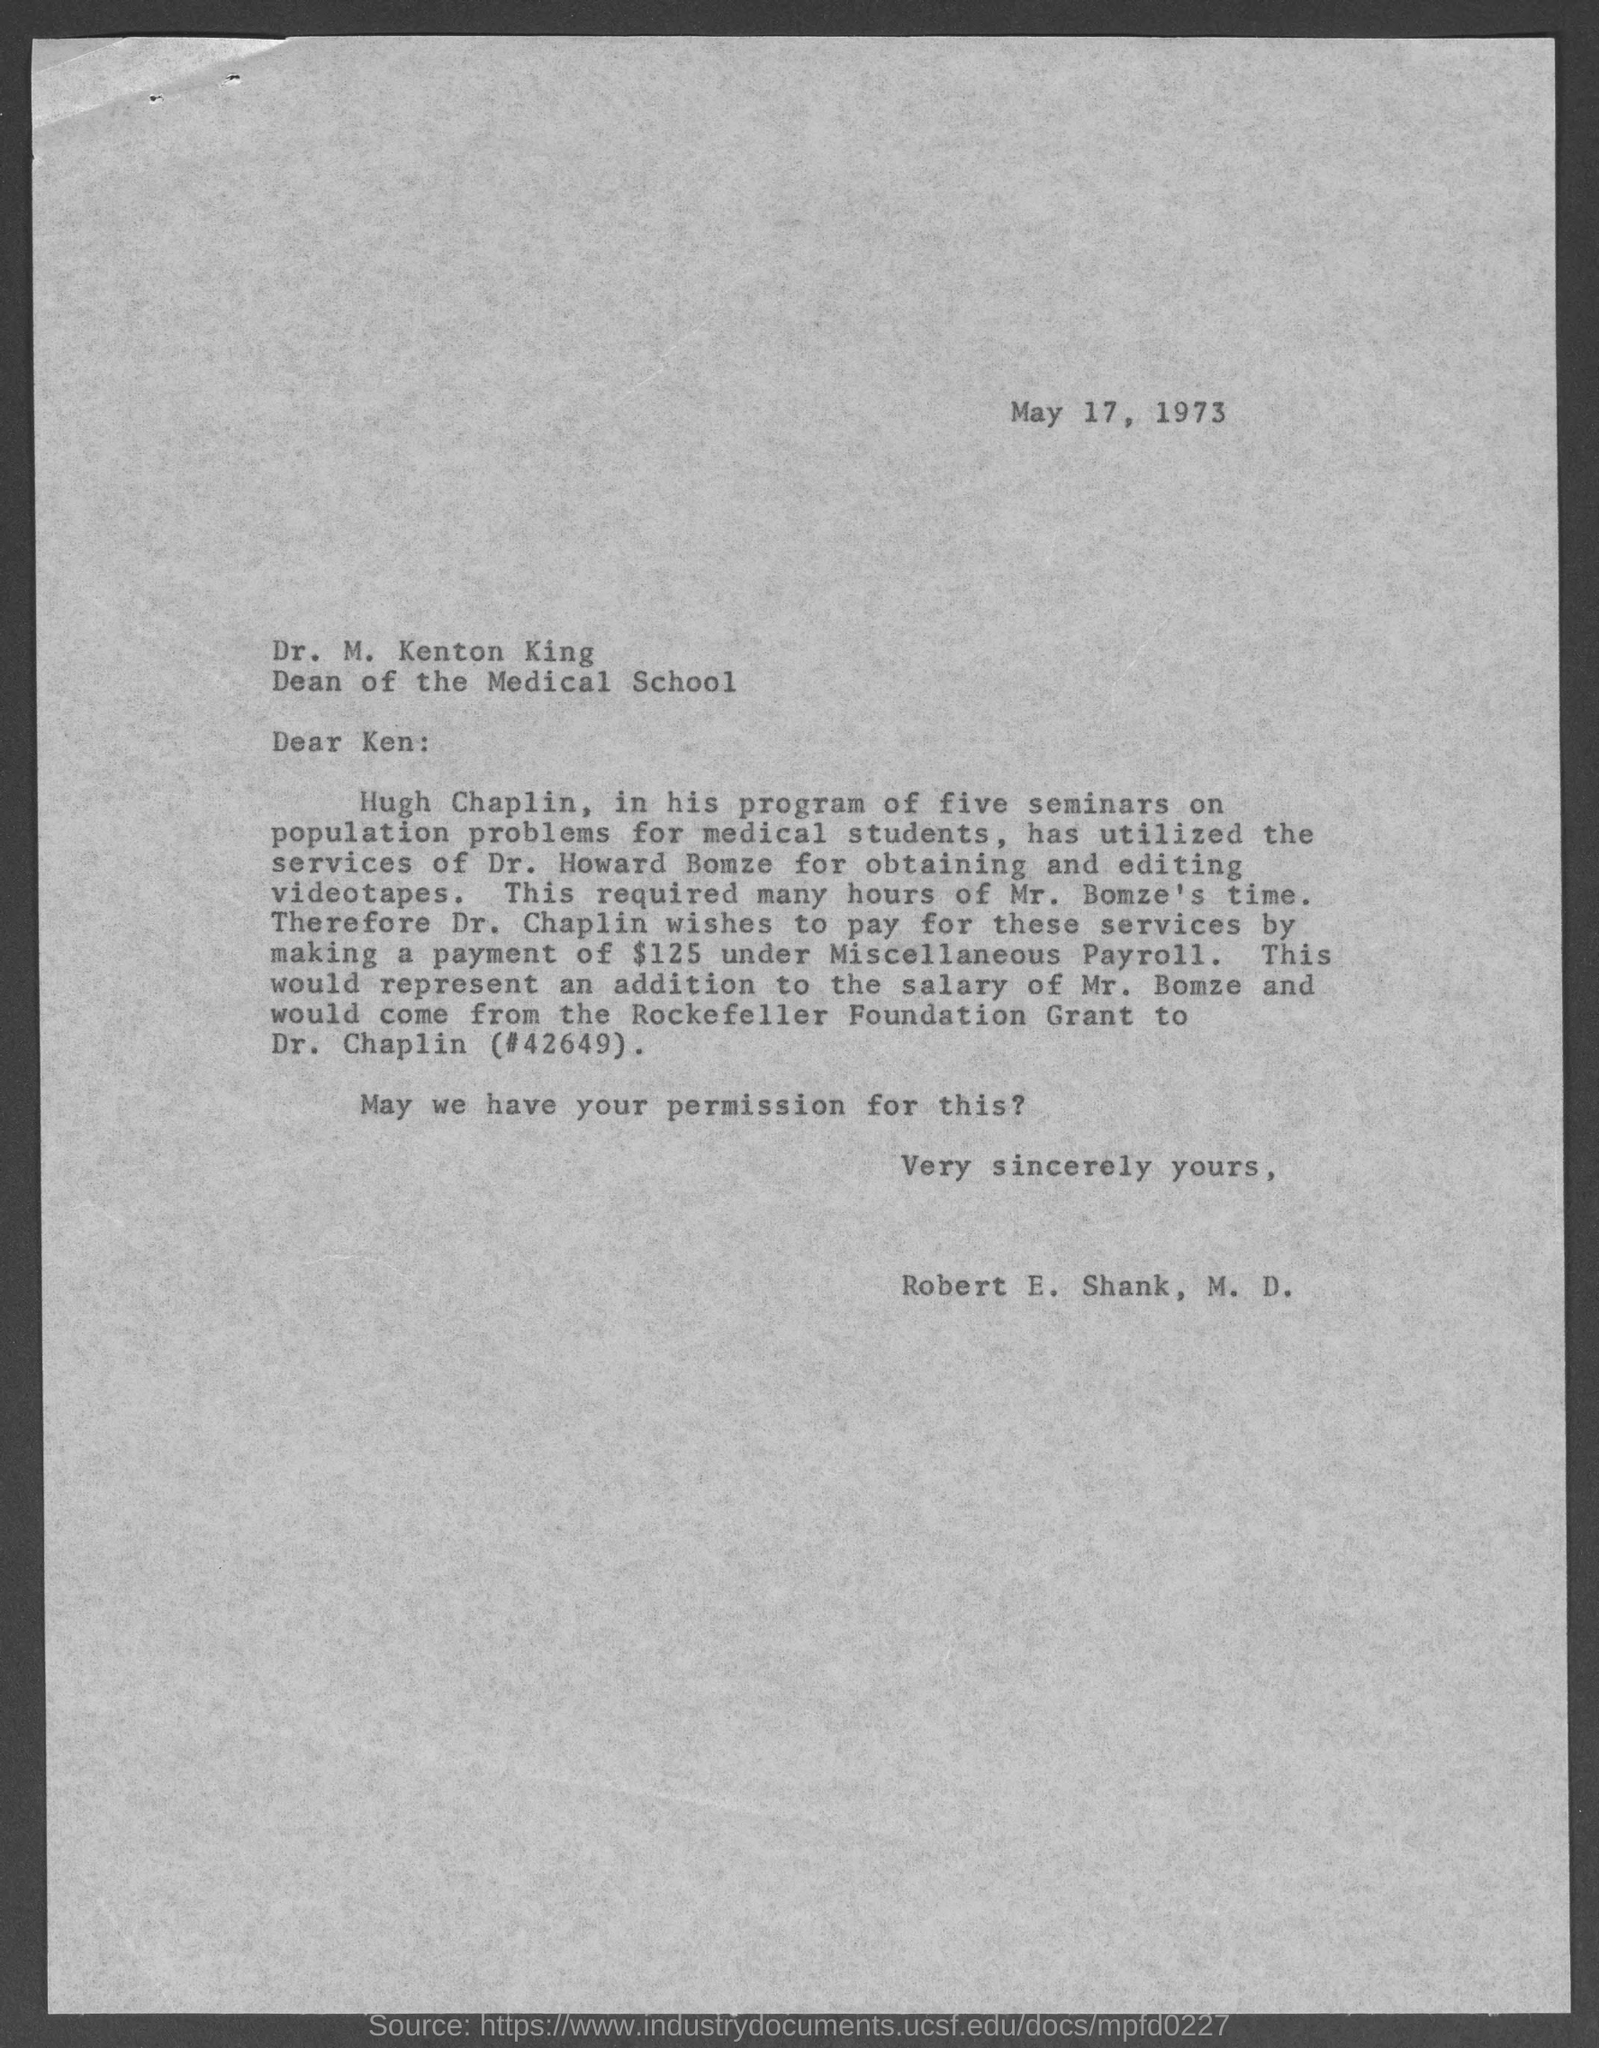When is the Memorandum dated on ?
Provide a short and direct response. May 17, 1973. Who is the Memorandum from ?
Make the answer very short. Robert E. Shank, M. D. 